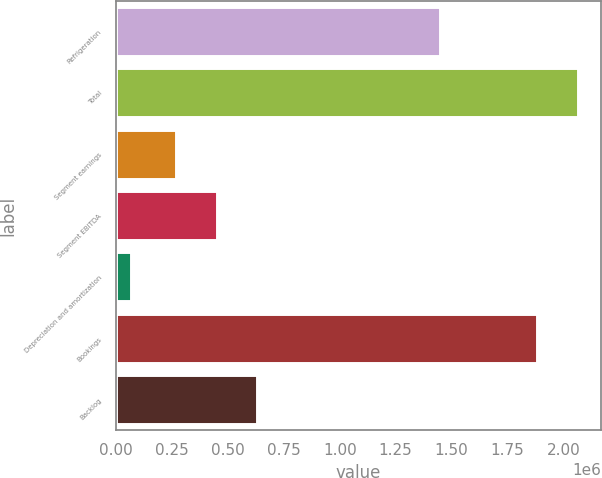<chart> <loc_0><loc_0><loc_500><loc_500><bar_chart><fcel>Refrigeration<fcel>Total<fcel>Segment earnings<fcel>Segment EBITDA<fcel>Depreciation and amortization<fcel>Bookings<fcel>Backlog<nl><fcel>1.44986e+06<fcel>2.0644e+06<fcel>267307<fcel>449368<fcel>67228<fcel>1.88234e+06<fcel>631429<nl></chart> 